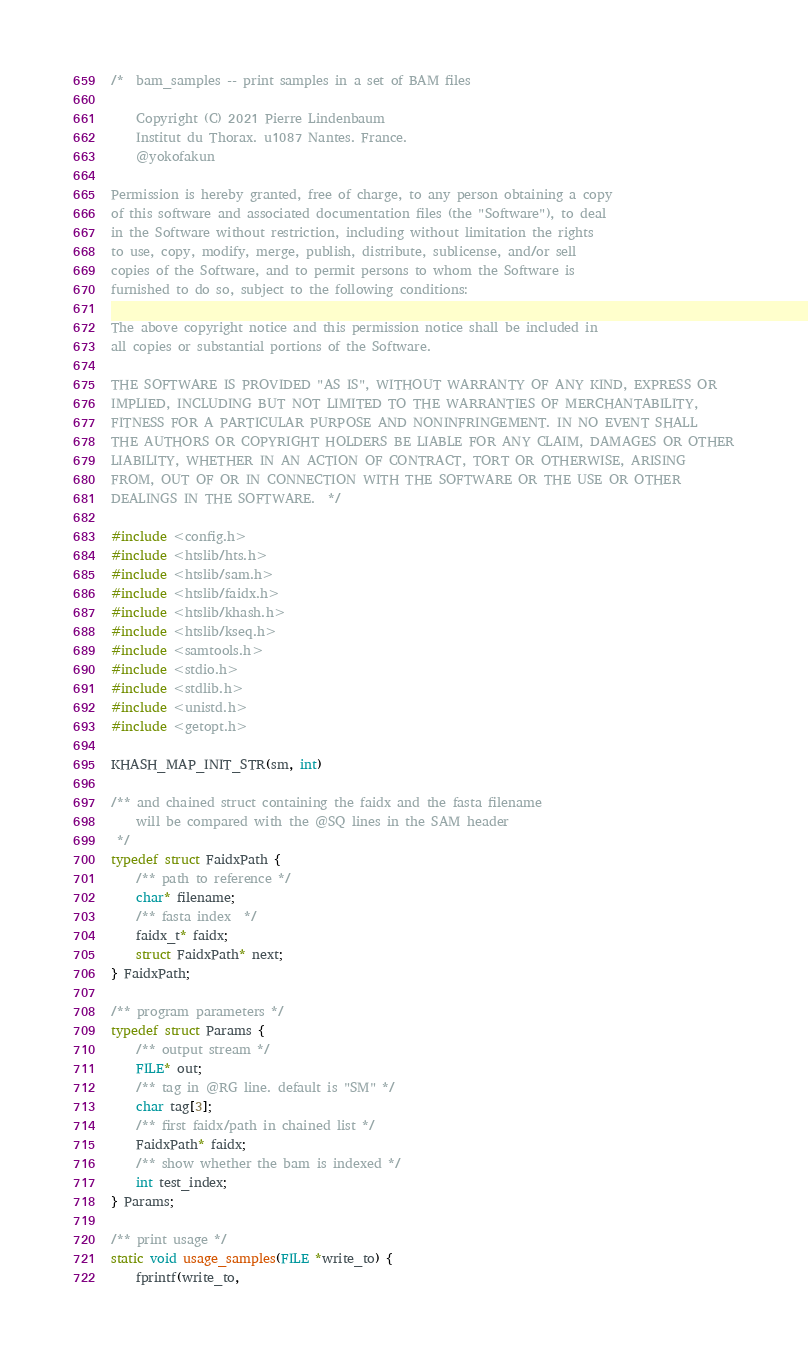<code> <loc_0><loc_0><loc_500><loc_500><_C_>/*  bam_samples -- print samples in a set of BAM files

    Copyright (C) 2021 Pierre Lindenbaum
    Institut du Thorax. u1087 Nantes. France.
    @yokofakun

Permission is hereby granted, free of charge, to any person obtaining a copy
of this software and associated documentation files (the "Software"), to deal
in the Software without restriction, including without limitation the rights
to use, copy, modify, merge, publish, distribute, sublicense, and/or sell
copies of the Software, and to permit persons to whom the Software is
furnished to do so, subject to the following conditions:

The above copyright notice and this permission notice shall be included in
all copies or substantial portions of the Software.

THE SOFTWARE IS PROVIDED "AS IS", WITHOUT WARRANTY OF ANY KIND, EXPRESS OR
IMPLIED, INCLUDING BUT NOT LIMITED TO THE WARRANTIES OF MERCHANTABILITY,
FITNESS FOR A PARTICULAR PURPOSE AND NONINFRINGEMENT. IN NO EVENT SHALL
THE AUTHORS OR COPYRIGHT HOLDERS BE LIABLE FOR ANY CLAIM, DAMAGES OR OTHER
LIABILITY, WHETHER IN AN ACTION OF CONTRACT, TORT OR OTHERWISE, ARISING
FROM, OUT OF OR IN CONNECTION WITH THE SOFTWARE OR THE USE OR OTHER
DEALINGS IN THE SOFTWARE.  */

#include <config.h>
#include <htslib/hts.h>
#include <htslib/sam.h>
#include <htslib/faidx.h>
#include <htslib/khash.h>
#include <htslib/kseq.h>
#include <samtools.h>
#include <stdio.h>
#include <stdlib.h>
#include <unistd.h>
#include <getopt.h>

KHASH_MAP_INIT_STR(sm, int)

/** and chained struct containing the faidx and the fasta filename
    will be compared with the @SQ lines in the SAM header
 */
typedef struct FaidxPath {
    /** path to reference */
    char* filename;
    /** fasta index  */
    faidx_t* faidx;
    struct FaidxPath* next;
} FaidxPath;

/** program parameters */
typedef struct Params {
    /** output stream */
    FILE* out;
    /** tag in @RG line. default is "SM" */
    char tag[3];
    /** first faidx/path in chained list */
    FaidxPath* faidx;
    /** show whether the bam is indexed */
    int test_index;
} Params;

/** print usage */
static void usage_samples(FILE *write_to) {
    fprintf(write_to,</code> 